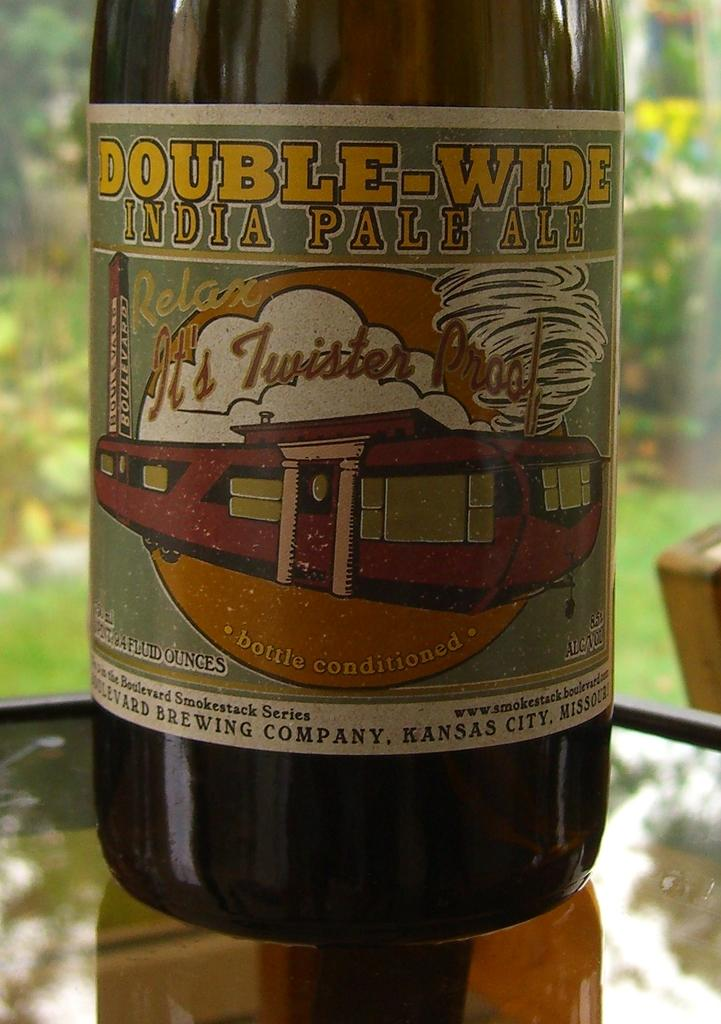<image>
Relay a brief, clear account of the picture shown. A bottle of Double-Wide India Pale Ale has a tornado on it. 